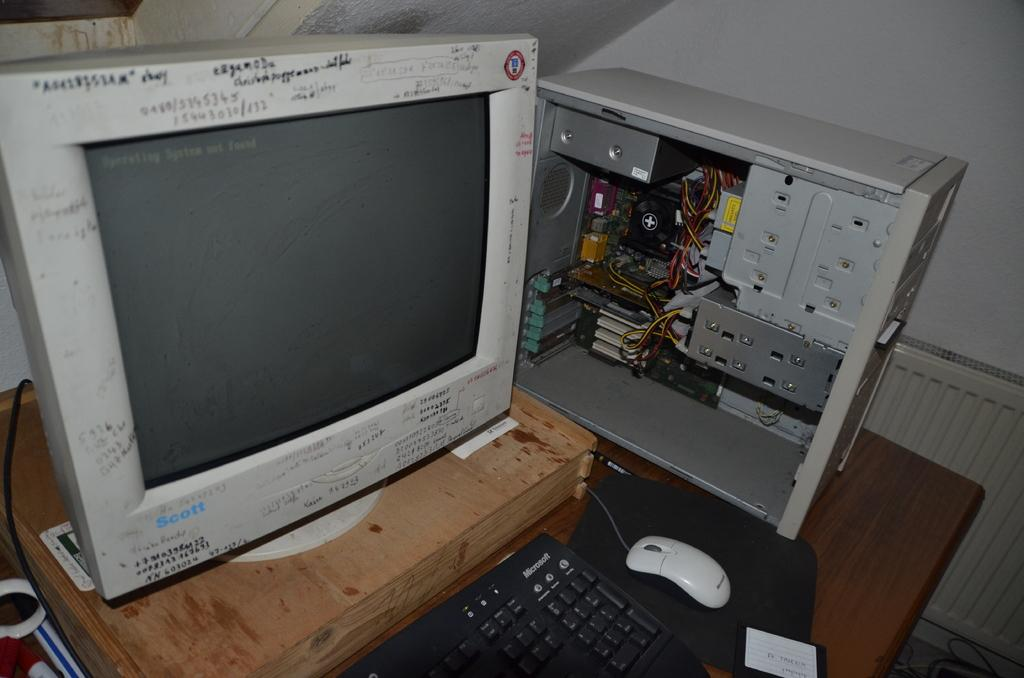<image>
Describe the image concisely. A computer sits on a table top, the mouse and keyboard are from Microsoft. 